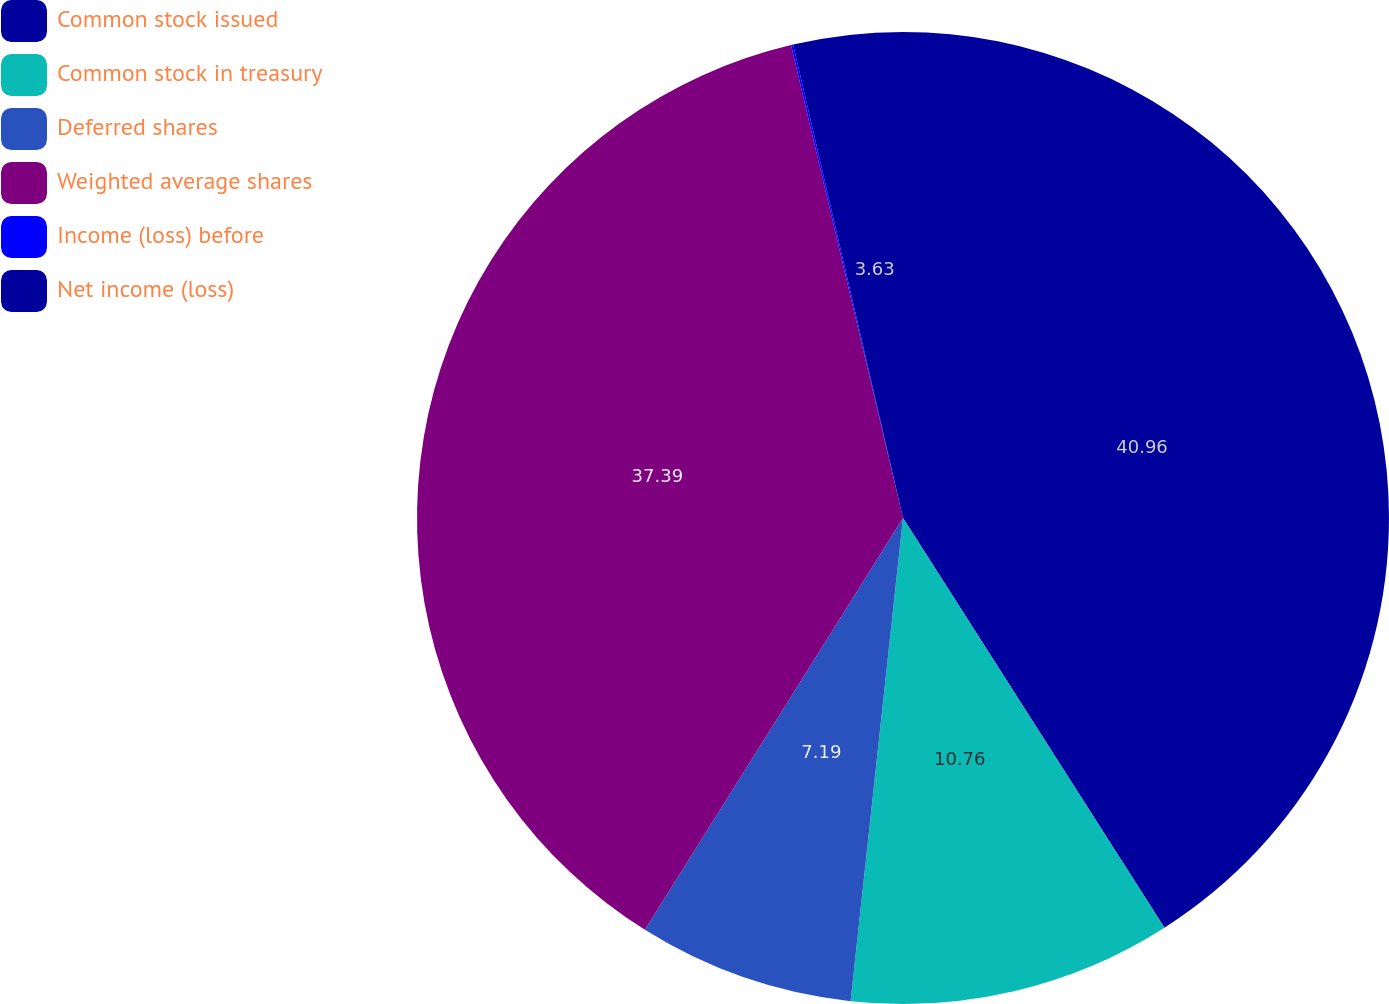Convert chart to OTSL. <chart><loc_0><loc_0><loc_500><loc_500><pie_chart><fcel>Common stock issued<fcel>Common stock in treasury<fcel>Deferred shares<fcel>Weighted average shares<fcel>Income (loss) before<fcel>Net income (loss)<nl><fcel>40.96%<fcel>10.76%<fcel>7.19%<fcel>37.39%<fcel>0.07%<fcel>3.63%<nl></chart> 